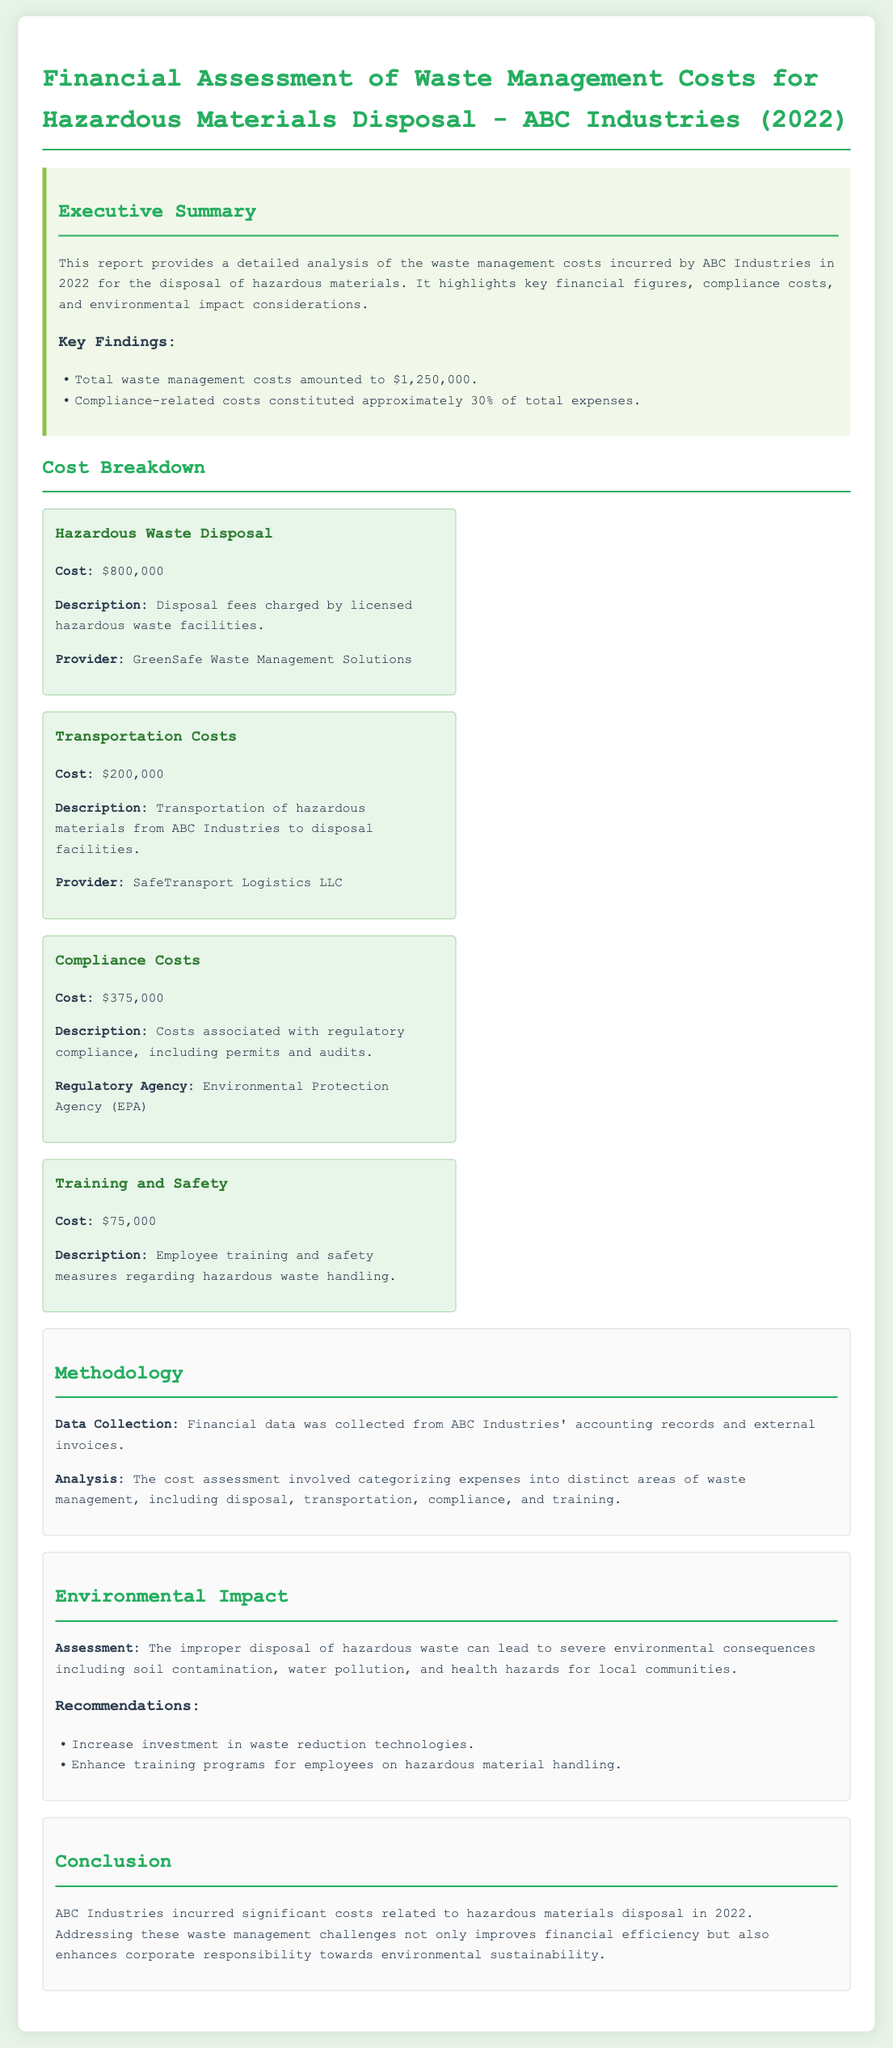What was the total waste management cost for ABC Industries in 2022? The total waste management cost is specifically stated in the executive summary as $1,250,000.
Answer: $1,250,000 What percentage of total expenses went to compliance-related costs? The document indicates that compliance-related costs constituted approximately 30% of the total expenses in the key findings section.
Answer: 30% Who provided the hazardous waste disposal service for ABC Industries? The document mentions that the hazardous waste disposal was handled by GreenSafe Waste Management Solutions in the cost breakdown section.
Answer: GreenSafe Waste Management Solutions What was the cost associated with employee training and safety? The training and safety costs are outlined in the cost breakdown, indicating they amounted to $75,000.
Answer: $75,000 What is one recommendation given to enhance environmental responsibility? The report provides recommendations in the environmental impact section, one being to increase investment in waste reduction technologies.
Answer: Increase investment in waste reduction technologies How was the financial data for the assessment collected? The methodology section states that financial data was collected from ABC Industries' accounting records and external invoices.
Answer: Accounting records and external invoices What was one of the environmental impacts mentioned regarding improper hazardous waste disposal? The document highlights severe environmental consequences like soil contamination in the environmental impact section.
Answer: Soil contamination What were the two main categories of costs incurred by ABC Industries for hazardous materials disposal? The cost breakdown categorizes the expenses into disposal and transportation costs, along with compliance and training.
Answer: Disposal and transportation costs 